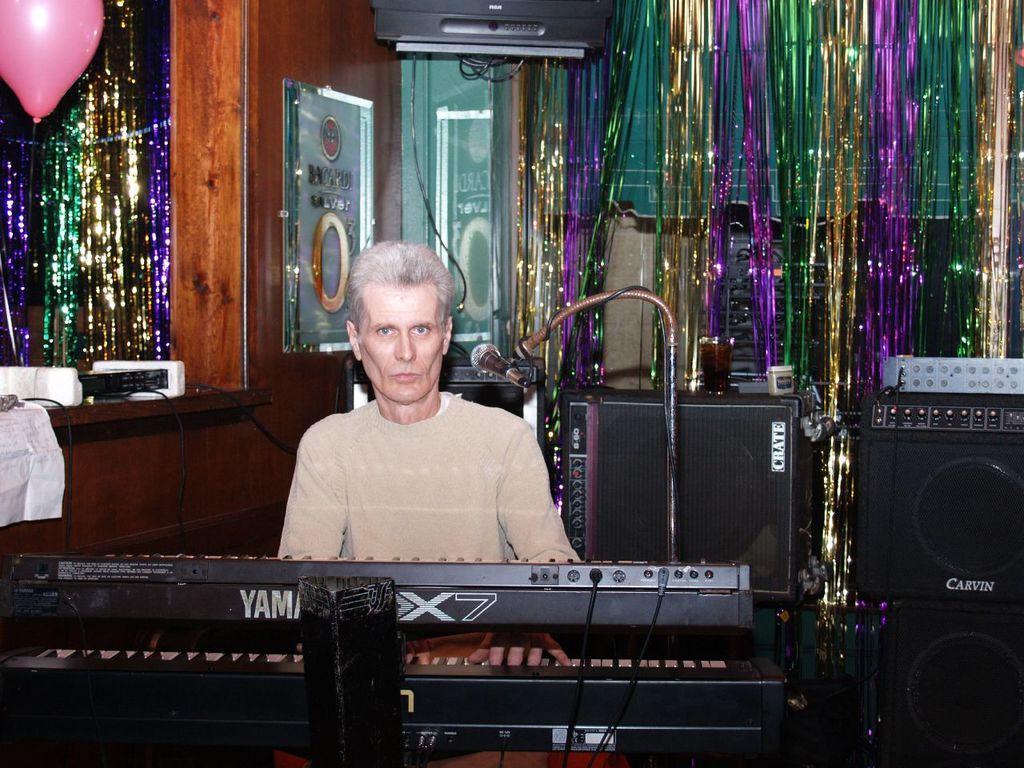In one or two sentences, can you explain what this image depicts? In this image, a person is sitting on the chair and playing keyboard. On the left and right side, decorations are visible. The walls are brown in color. In the right bottom, speakers are visible. This image is taken inside a room. 